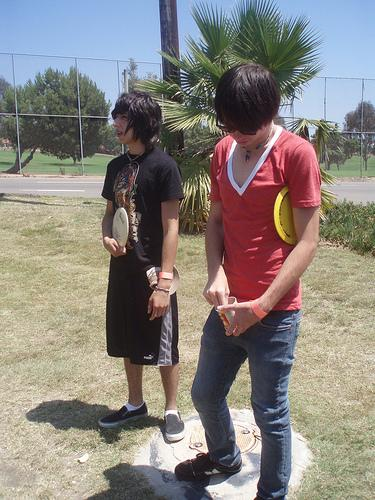Identify the main colors of the objects worn by the two boys. The boys are wearing red shirts, black shorts, and white socks with black sneakers. What are the boys playing, and what are they holding? The boys are playing disc golf and holding frisbees - one has a yellow disc and the other has a white disc. How many people are present in the image, and what are they wearing? There are two boys in the image wearing red shirts, one has shorts and the other has jeans. What footwear are the boys wearing, and what is unique about one of the shoes? The boys are wearing black slip-on sneakers, and one of the boys has visible shoelaces on his shoe. What type of accessory does one of the boys have on his face? One of the boys is wearing sunglasses on his face. What is the state of the grass in the image, and can any shadows be seen? The grass is dry, and shadows of the boys can be seen on the ground. What type of tree can be seen in the image, and what is a specific feature of the tree? There is a palm tree in the background, with a palm frond visible on it. Describe the fence that can be seen in the background of the image. There is a mesh fence behind the road in the background of the image. What is unique about the boy on the left's shirt, and what is under his arm? The boy on the left has a v-neck cut red shirt and a yellow frisbee under his arm. How many types of bottom-wear are the two men wearing? The two men are wearing different types of bottom-wear: one with jeans and the other with shorts. 